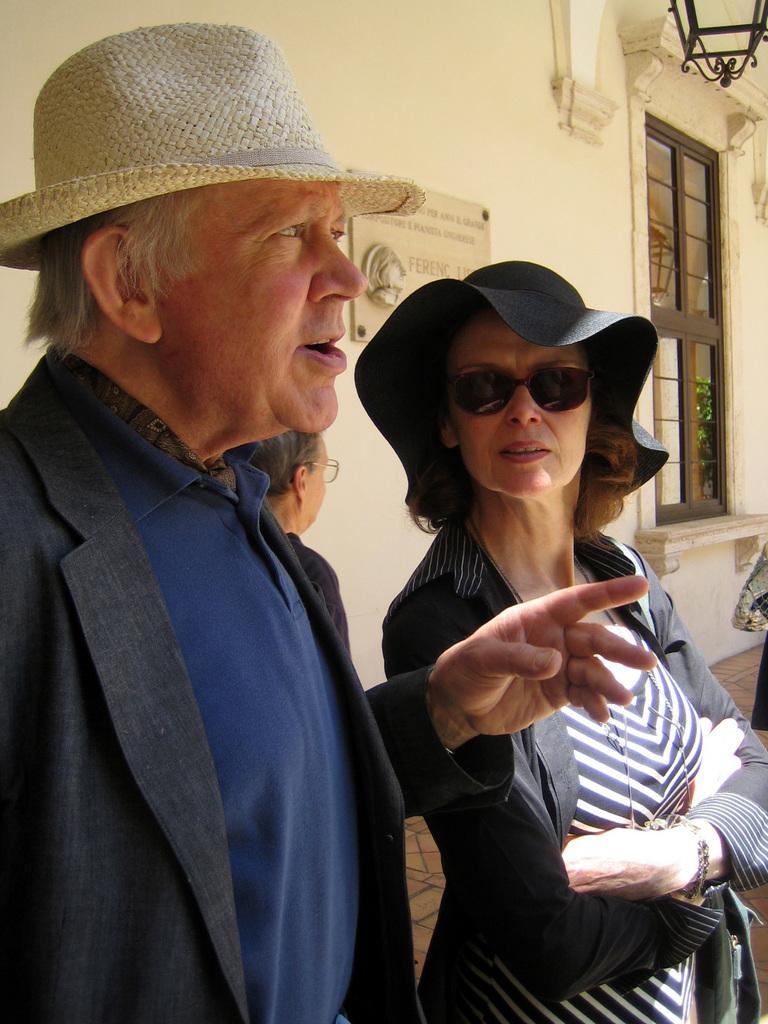How would you summarize this image in a sentence or two? In this picture we can see there are three people standing and a man in the blazer is explaining something. Behind the people there is a wall with a name board and a window and on the window we can see the reflection of a tree. At the top there is a light. 